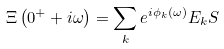Convert formula to latex. <formula><loc_0><loc_0><loc_500><loc_500>\Xi \left ( 0 ^ { + } + i \omega \right ) = \sum _ { k } e ^ { i \phi _ { k } \left ( \omega \right ) } E _ { k } S</formula> 